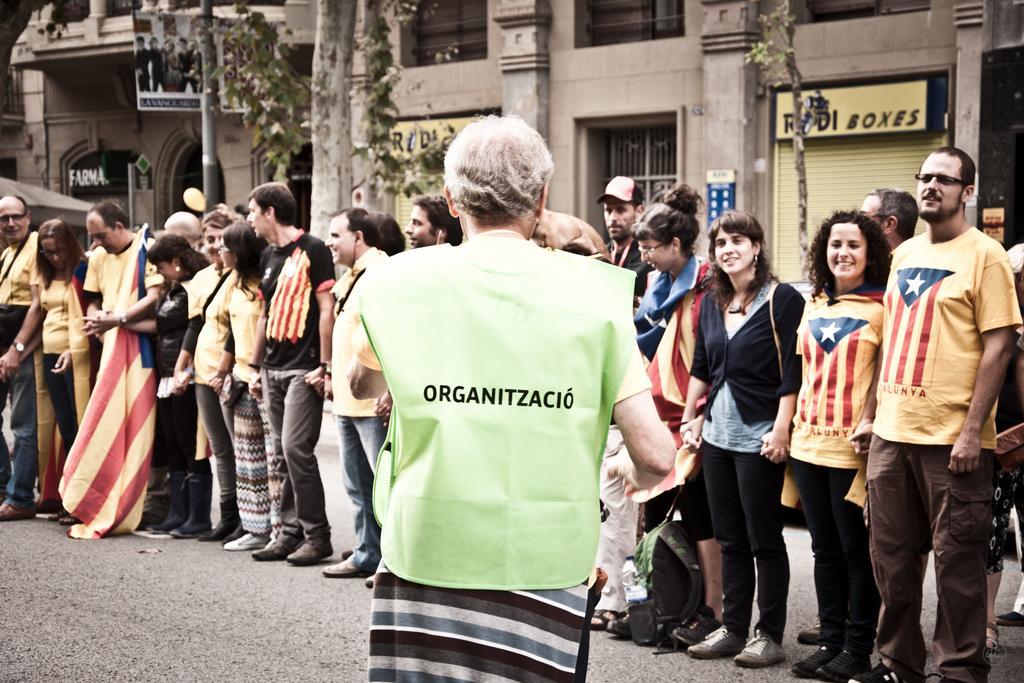In one or two sentences, can you explain what this image depicts? in this image we can see few people standing on the road, a person is holding a flag, there are shutters, boards with text to the buildings and few trees in the background. 